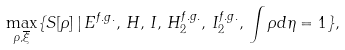<formula> <loc_0><loc_0><loc_500><loc_500>\max _ { \rho , \overline { \xi } } \{ S [ \rho ] \, | \, E ^ { f . g . } , \, H , \, I , \, H _ { 2 } ^ { f . g . } , \, I _ { 2 } ^ { f . g . } , \, \int \rho d \eta = 1 \} ,</formula> 